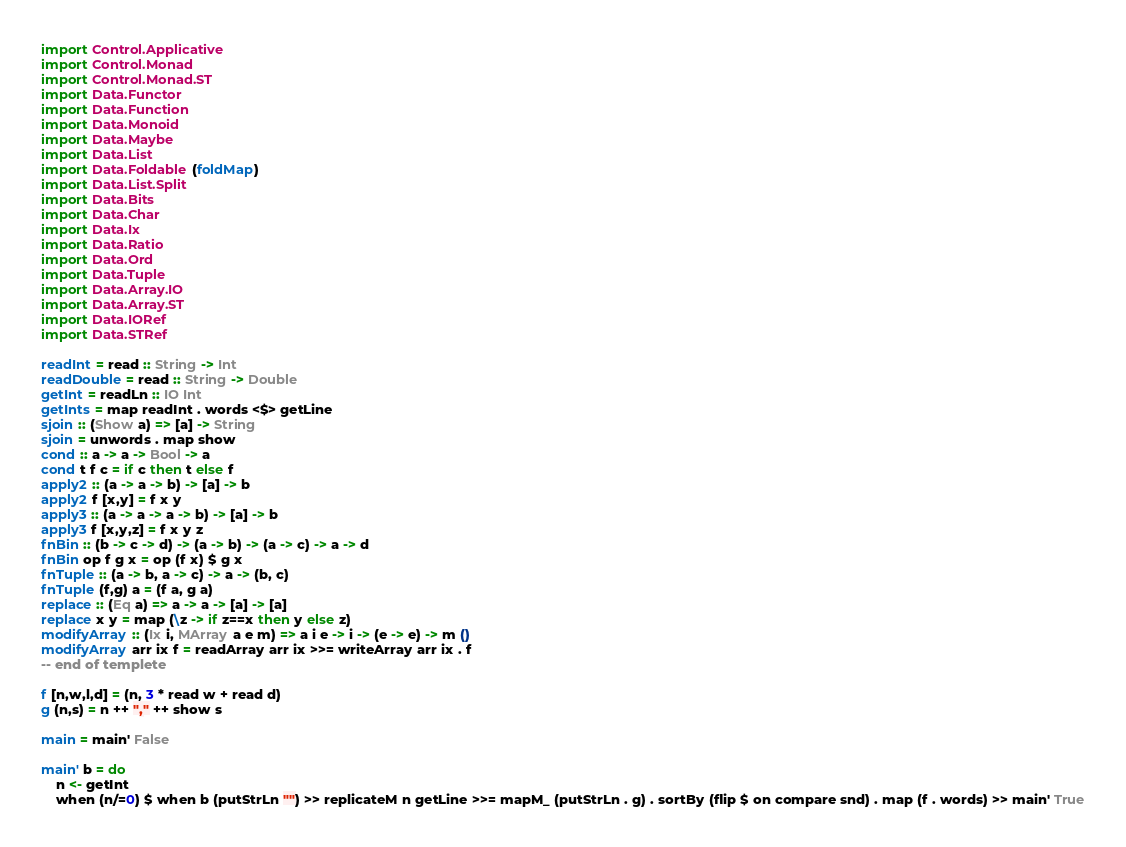<code> <loc_0><loc_0><loc_500><loc_500><_Haskell_>import Control.Applicative
import Control.Monad
import Control.Monad.ST
import Data.Functor
import Data.Function
import Data.Monoid
import Data.Maybe
import Data.List
import Data.Foldable (foldMap)
import Data.List.Split
import Data.Bits
import Data.Char
import Data.Ix
import Data.Ratio
import Data.Ord
import Data.Tuple
import Data.Array.IO
import Data.Array.ST
import Data.IORef
import Data.STRef
 
readInt = read :: String -> Int
readDouble = read :: String -> Double
getInt = readLn :: IO Int
getInts = map readInt . words <$> getLine
sjoin :: (Show a) => [a] -> String
sjoin = unwords . map show
cond :: a -> a -> Bool -> a
cond t f c = if c then t else f
apply2 :: (a -> a -> b) -> [a] -> b
apply2 f [x,y] = f x y
apply3 :: (a -> a -> a -> b) -> [a] -> b
apply3 f [x,y,z] = f x y z
fnBin :: (b -> c -> d) -> (a -> b) -> (a -> c) -> a -> d
fnBin op f g x = op (f x) $ g x
fnTuple :: (a -> b, a -> c) -> a -> (b, c)
fnTuple (f,g) a = (f a, g a)
replace :: (Eq a) => a -> a -> [a] -> [a]
replace x y = map (\z -> if z==x then y else z)
modifyArray :: (Ix i, MArray a e m) => a i e -> i -> (e -> e) -> m ()
modifyArray arr ix f = readArray arr ix >>= writeArray arr ix . f
-- end of templete

f [n,w,l,d] = (n, 3 * read w + read d)
g (n,s) = n ++ "," ++ show s

main = main' False

main' b = do
    n <- getInt
    when (n/=0) $ when b (putStrLn "") >> replicateM n getLine >>= mapM_ (putStrLn . g) . sortBy (flip $ on compare snd) . map (f . words) >> main' True</code> 